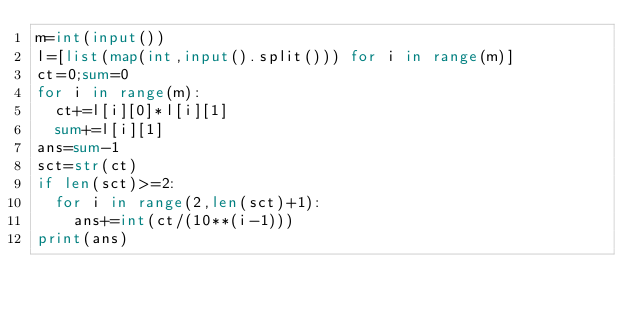<code> <loc_0><loc_0><loc_500><loc_500><_Python_>m=int(input())
l=[list(map(int,input().split())) for i in range(m)]
ct=0;sum=0
for i in range(m):
  ct+=l[i][0]*l[i][1]
  sum+=l[i][1]
ans=sum-1
sct=str(ct)
if len(sct)>=2:
  for i in range(2,len(sct)+1):
    ans+=int(ct/(10**(i-1)))
print(ans)</code> 